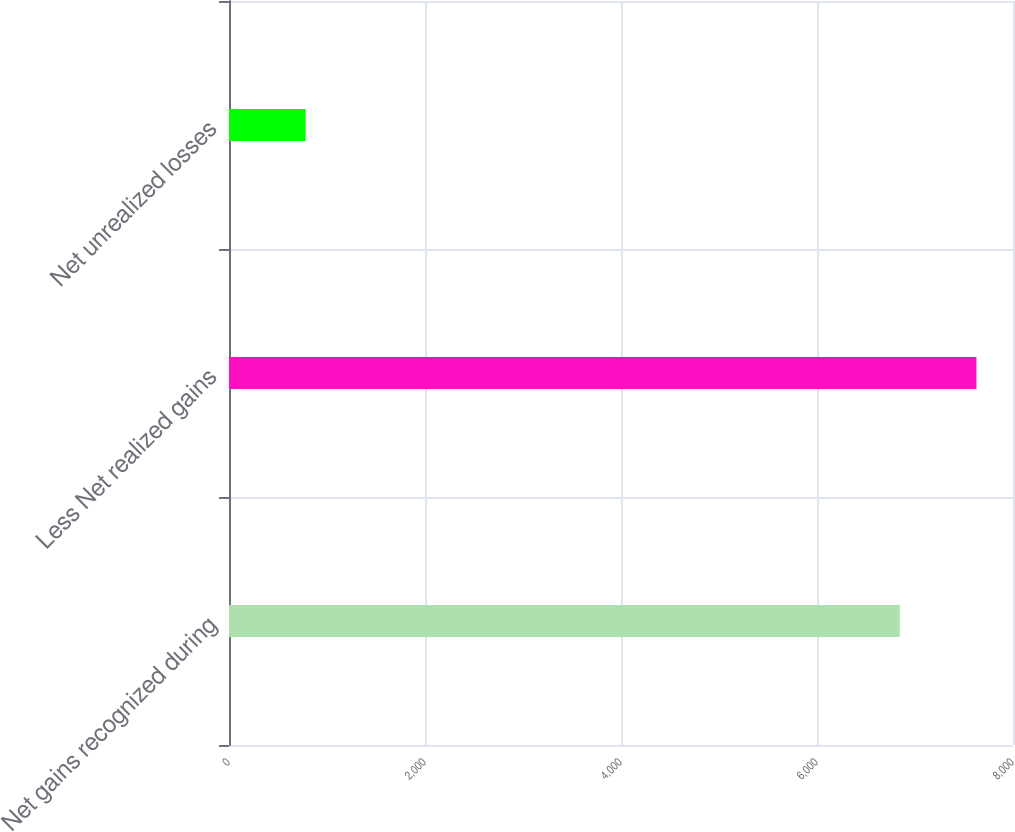Convert chart. <chart><loc_0><loc_0><loc_500><loc_500><bar_chart><fcel>Net gains recognized during<fcel>Less Net realized gains<fcel>Net unrealized losses<nl><fcel>6845<fcel>7627<fcel>782<nl></chart> 